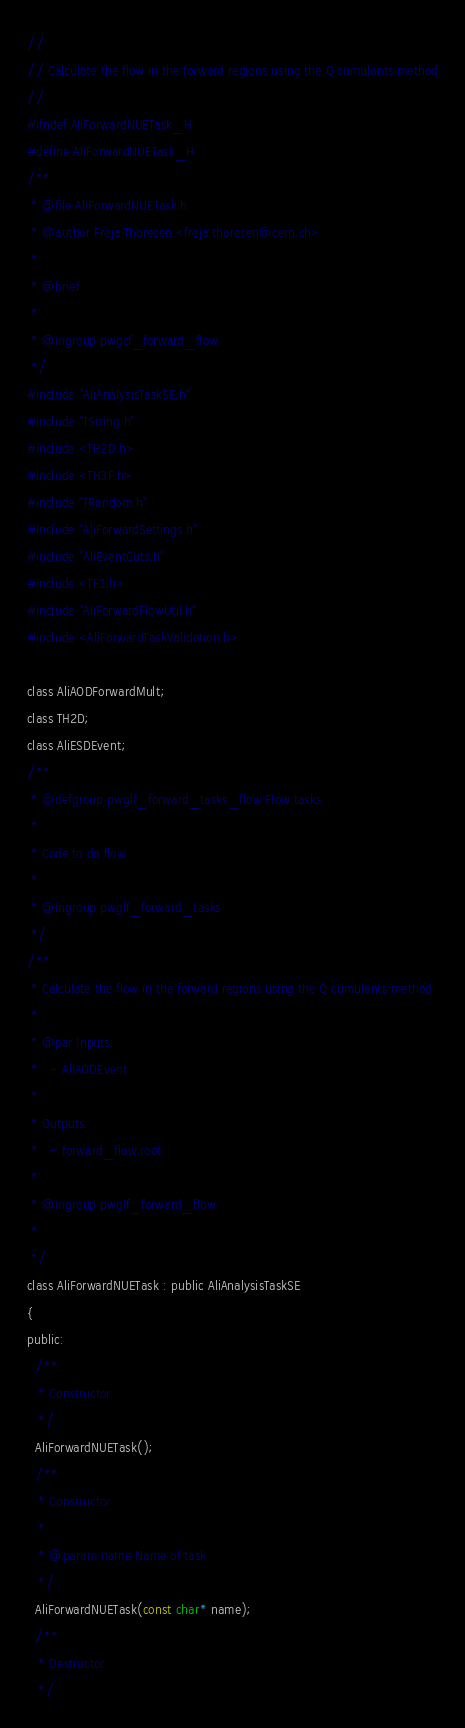<code> <loc_0><loc_0><loc_500><loc_500><_C_>//
// Calculate the flow in the forward regions using the Q cumulants method
//
#ifndef AliForwardNUETask_H
#define AliForwardNUETask_H
/**
 * @file AliForwardNUETask.h
 * @author Freja Thoresen <freja.thoresen@cern.ch>
 *
 * @brief
 *
 * @ingroup pwgcf_forward_flow
 */
#include "AliAnalysisTaskSE.h"
#include "TString.h"
#include <TH2D.h>
#include <TH3F.h>
#include "TRandom.h"
#include "AliForwardSettings.h"
#include "AliEventCuts.h"
#include <TF1.h>
#include "AliForwardFlowUtil.h"
#include <AliForwardTaskValidation.h>

class AliAODForwardMult;
class TH2D;
class AliESDEvent;
/**
 * @defgroup pwglf_forward_tasks_flow Flow tasks
 *
 * Code to do flow
 *
 * @ingroup pwglf_forward_tasks
 */
/**
 * Calculate the flow in the forward regions using the Q cumulants method
 *
 * @par Inputs:
 *   - AliAODEvent
 *
 * Outputs:
 *   - forward_flow.root
 *
 * @ingroup pwglf_forward_flow
 *
 */
class AliForwardNUETask : public AliAnalysisTaskSE
{
public:
  /**
   * Constructor
   */
  AliForwardNUETask();
  /**
   * Constructor
   *
   * @param name Name of task
   */
  AliForwardNUETask(const char* name);
  /**
   * Destructor
   */</code> 